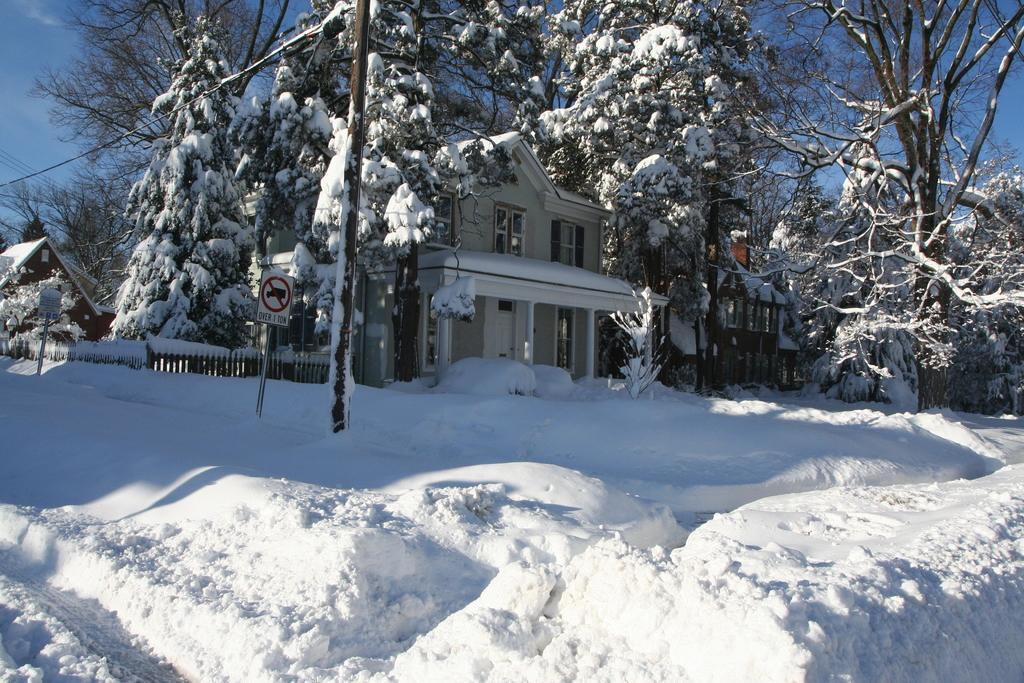Describe this image in one or two sentences. As we can see in the image there is snow, trees, buildings, fence and sky. 